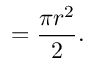Convert formula to latex. <formula><loc_0><loc_0><loc_500><loc_500>= { \frac { \pi r ^ { 2 } } { 2 } } .</formula> 